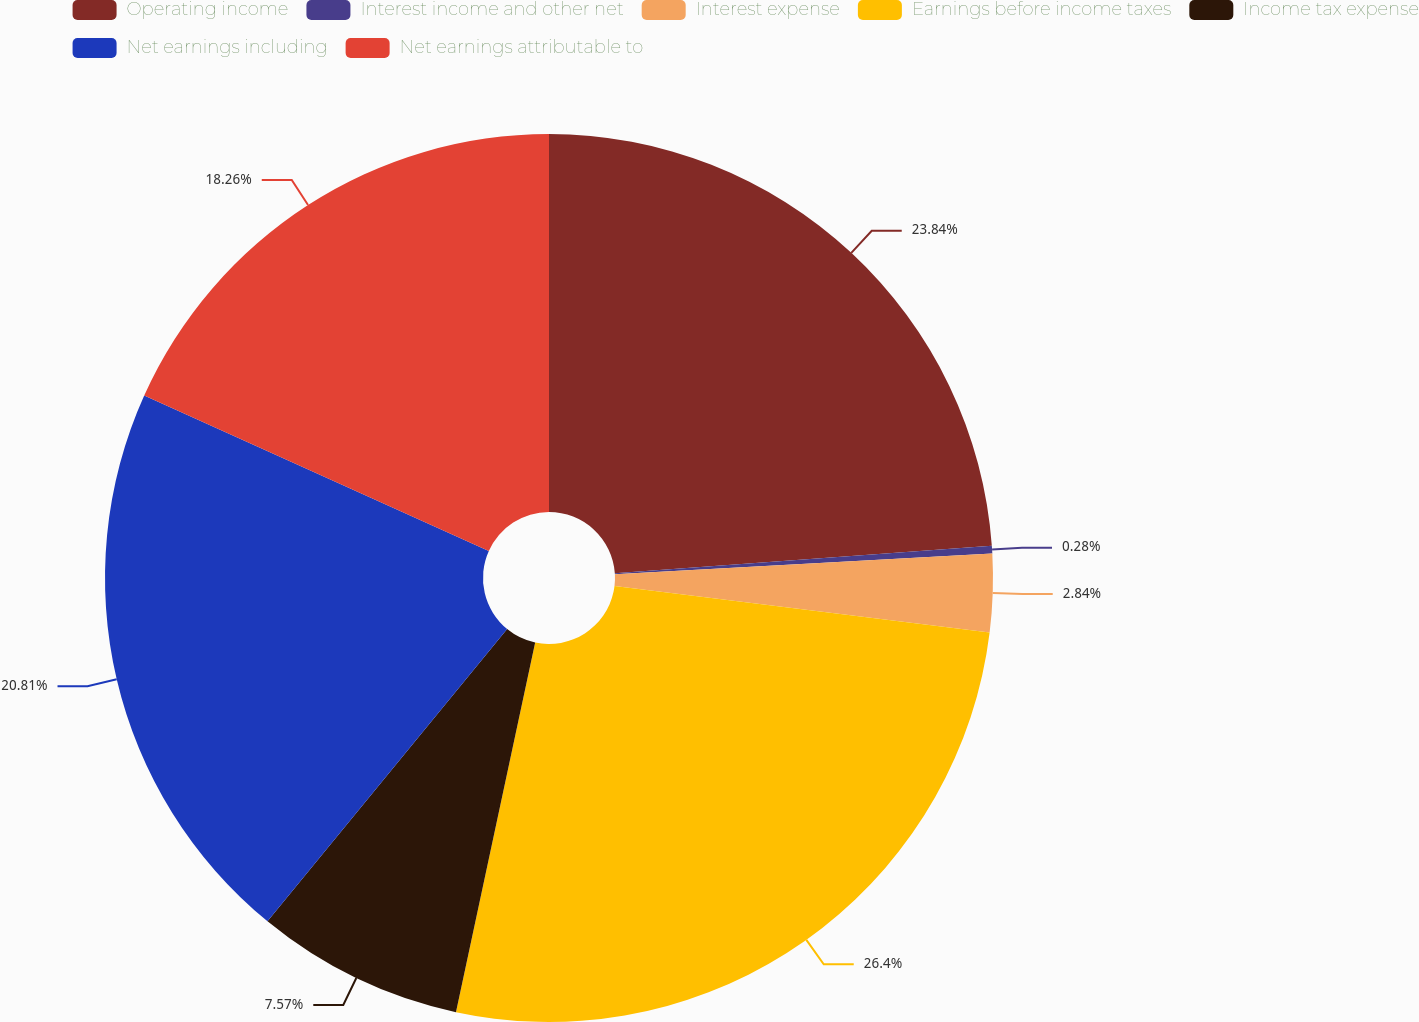<chart> <loc_0><loc_0><loc_500><loc_500><pie_chart><fcel>Operating income<fcel>Interest income and other net<fcel>Interest expense<fcel>Earnings before income taxes<fcel>Income tax expense<fcel>Net earnings including<fcel>Net earnings attributable to<nl><fcel>23.84%<fcel>0.28%<fcel>2.84%<fcel>26.4%<fcel>7.57%<fcel>20.81%<fcel>18.26%<nl></chart> 